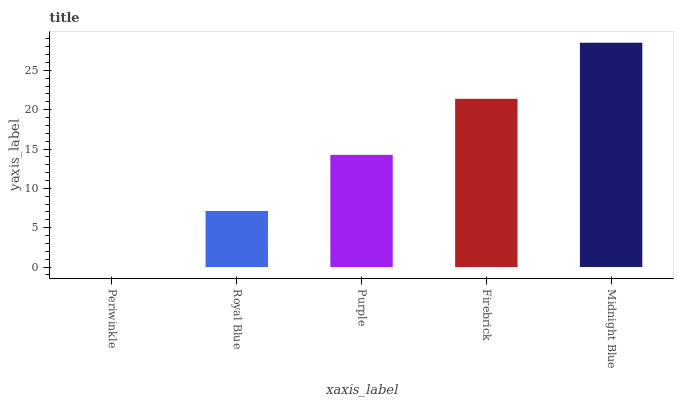Is Periwinkle the minimum?
Answer yes or no. Yes. Is Midnight Blue the maximum?
Answer yes or no. Yes. Is Royal Blue the minimum?
Answer yes or no. No. Is Royal Blue the maximum?
Answer yes or no. No. Is Royal Blue greater than Periwinkle?
Answer yes or no. Yes. Is Periwinkle less than Royal Blue?
Answer yes or no. Yes. Is Periwinkle greater than Royal Blue?
Answer yes or no. No. Is Royal Blue less than Periwinkle?
Answer yes or no. No. Is Purple the high median?
Answer yes or no. Yes. Is Purple the low median?
Answer yes or no. Yes. Is Periwinkle the high median?
Answer yes or no. No. Is Periwinkle the low median?
Answer yes or no. No. 